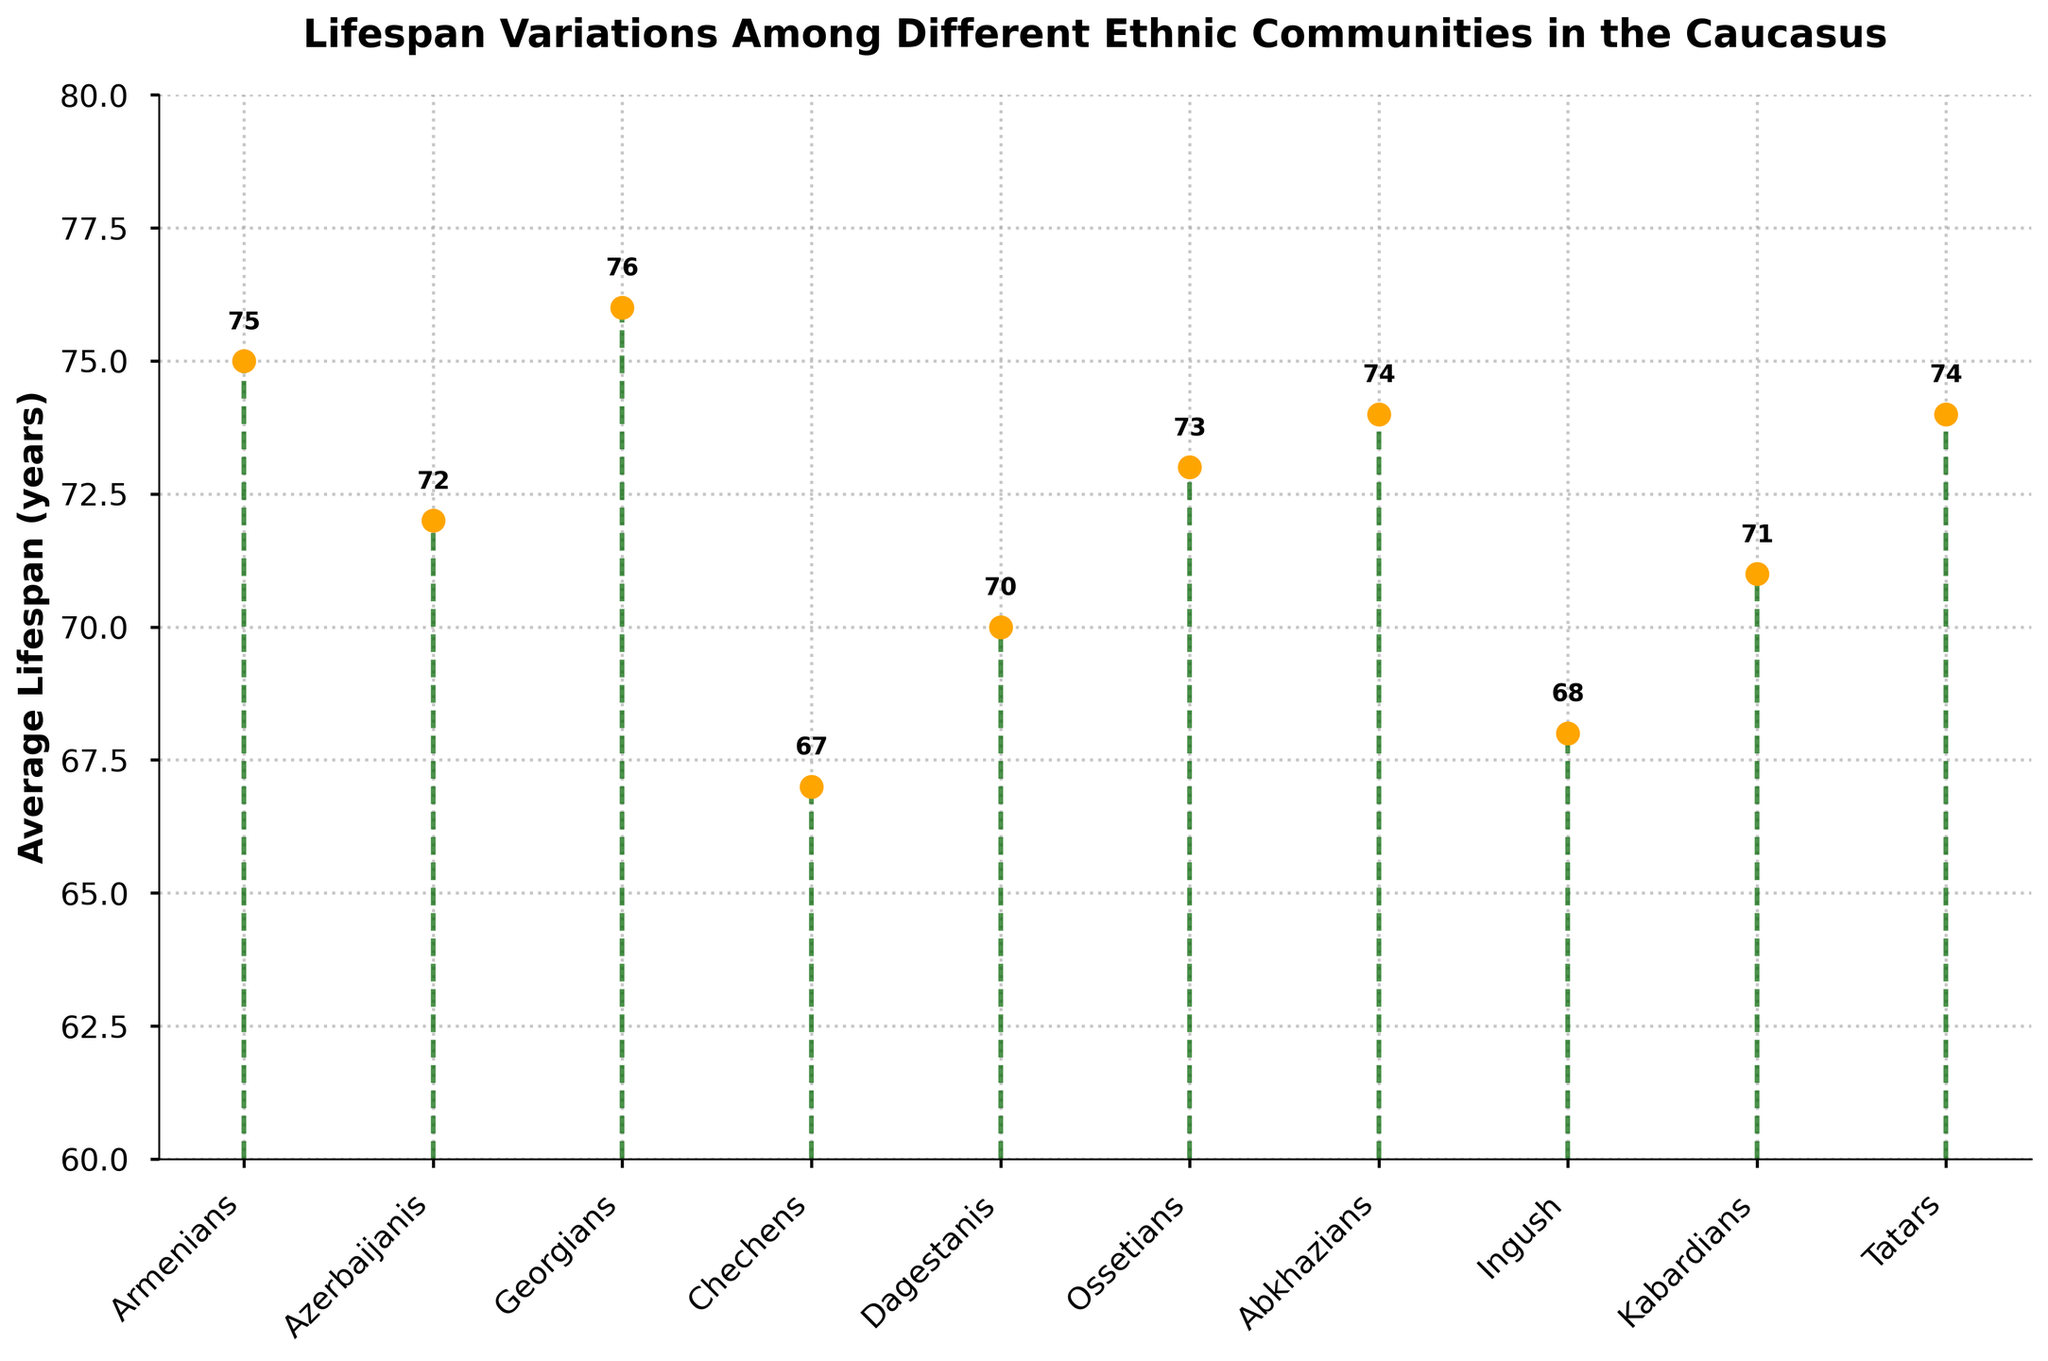What's the title of the figure? The title can be found at the top of the plot. It states, "Lifespan Variations Among Different Ethnic Communities in the Caucasus."
Answer: Lifespan Variations Among Different Ethnic Communities in the Caucasus What is the average lifespan of Armenians? Locate Armenians in the plot and read the corresponding lifespan value. It shows 75 years.
Answer: 75 How many ethnic communities are represented in the figure? Count the number of unique data points (ethnic communities) plotted along the x-axis. There are 10 ethnic communities.
Answer: 10 Which ethnic community has the highest average lifespan? Identify the data point with the highest marker value. Georgians have the highest average lifespan of 76 years.
Answer: Georgians What is the difference in average lifespan between Chechens and Georgians? Subtract the average lifespan of Chechens (67 years) from Georgians (76 years). The difference is 76 - 67 = 9 years.
Answer: 9 What is the average lifespan of Dagestanis rounded to the nearest whole number? Locate Dagestanis in the plot and read the corresponding lifespan value, which is 70 years.
Answer: 70 Which two ethnic communities have equal average lifespans? Identify the data points that share the same marker value. Abkhazians and Tatars both have an average lifespan of 74 years.
Answer: Abkhazians, Tatars Rank the ethnic communities from highest to lowest average lifespan. Observe the values of each community and order them from highest to lowest. The order is: Georgians (76), Armenians (75), Abkhazians (74), Tatars (74), Ossetians (73), Azerbaijanis (72), Kabardians (71), Dagestanis (70), Ingush (68), Chechens (67).
Answer: Georgians, Armenians, Abkhazians, Tatars, Ossetians, Azerbaijanis, Kabardians, Dagestanis, Ingush, Chechens How does the average lifespan of Kabardians compare to Ingush? Locate and compare the marker values of Kabardians (71) and Ingush (68). Kabardians have a higher average lifespan than Ingush.
Answer: Kabardians have a higher average lifespan What is the average of all the average lifespans represented? Sum all the average lifespans and divide by the number of communities (10). Calculation: (75 + 72 + 76 + 67 + 70 + 73 + 74 + 68 + 71 + 74)/10 = 72.
Answer: 72 